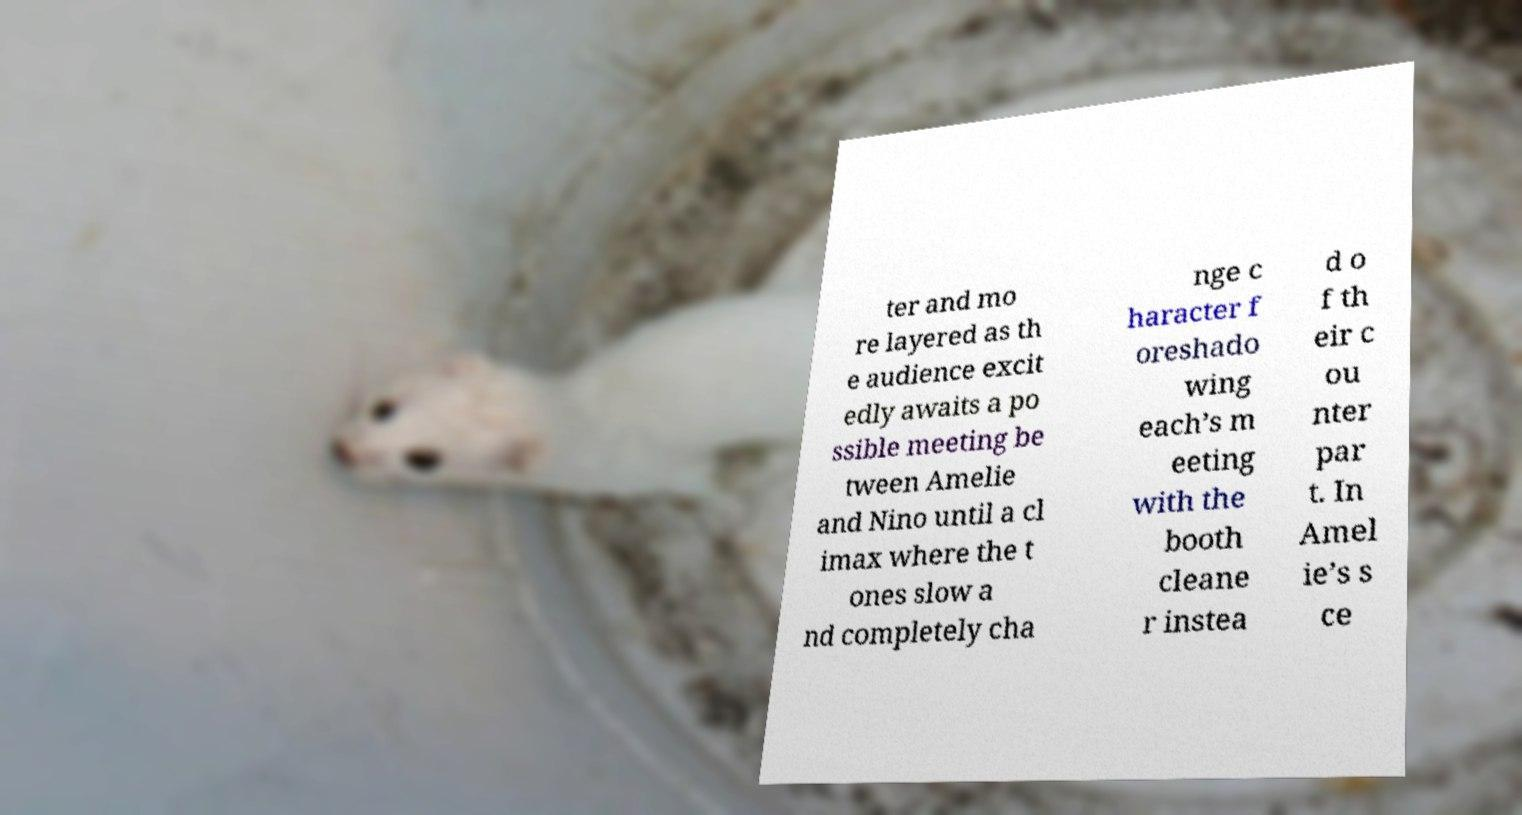Could you assist in decoding the text presented in this image and type it out clearly? ter and mo re layered as th e audience excit edly awaits a po ssible meeting be tween Amelie and Nino until a cl imax where the t ones slow a nd completely cha nge c haracter f oreshado wing each’s m eeting with the booth cleane r instea d o f th eir c ou nter par t. In Amel ie’s s ce 